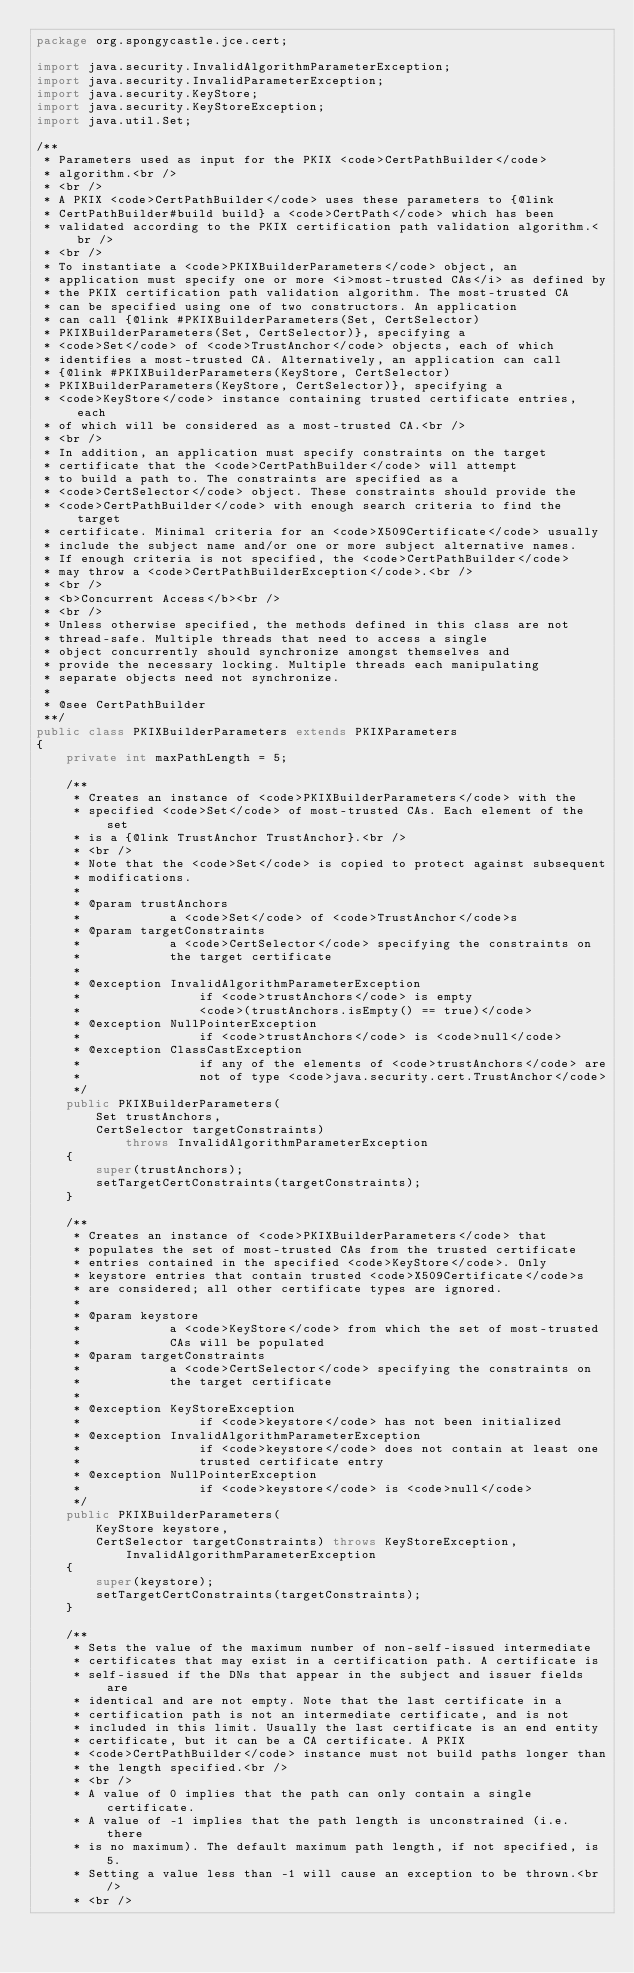Convert code to text. <code><loc_0><loc_0><loc_500><loc_500><_Java_>package org.spongycastle.jce.cert;

import java.security.InvalidAlgorithmParameterException;
import java.security.InvalidParameterException;
import java.security.KeyStore;
import java.security.KeyStoreException;
import java.util.Set;

/**
 * Parameters used as input for the PKIX <code>CertPathBuilder</code> 
 * algorithm.<br />
 * <br />
 * A PKIX <code>CertPathBuilder</code> uses these parameters to {@link 
 * CertPathBuilder#build build} a <code>CertPath</code> which has been 
 * validated according to the PKIX certification path validation algorithm.<br />
 * <br />
 * To instantiate a <code>PKIXBuilderParameters</code> object, an
 * application must specify one or more <i>most-trusted CAs</i> as defined by
 * the PKIX certification path validation algorithm. The most-trusted CA 
 * can be specified using one of two constructors. An application 
 * can call {@link #PKIXBuilderParameters(Set, CertSelector) 
 * PKIXBuilderParameters(Set, CertSelector)}, specifying a 
 * <code>Set</code> of <code>TrustAnchor</code> objects, each of which 
 * identifies a most-trusted CA. Alternatively, an application can call 
 * {@link #PKIXBuilderParameters(KeyStore, CertSelector)
 * PKIXBuilderParameters(KeyStore, CertSelector)}, specifying a 
 * <code>KeyStore</code> instance containing trusted certificate entries, each 
 * of which will be considered as a most-trusted CA.<br />
 * <br />
 * In addition, an application must specify constraints on the target 
 * certificate that the <code>CertPathBuilder</code> will attempt 
 * to build a path to. The constraints are specified as a 
 * <code>CertSelector</code> object. These constraints should provide the 
 * <code>CertPathBuilder</code> with enough search criteria to find the target 
 * certificate. Minimal criteria for an <code>X509Certificate</code> usually 
 * include the subject name and/or one or more subject alternative names.
 * If enough criteria is not specified, the <code>CertPathBuilder</code> 
 * may throw a <code>CertPathBuilderException</code>.<br />
 * <br />
 * <b>Concurrent Access</b><br />
 * <br />
 * Unless otherwise specified, the methods defined in this class are not
 * thread-safe. Multiple threads that need to access a single
 * object concurrently should synchronize amongst themselves and
 * provide the necessary locking. Multiple threads each manipulating
 * separate objects need not synchronize.
 *
 * @see CertPathBuilder
 **/
public class PKIXBuilderParameters extends PKIXParameters
{
    private int maxPathLength = 5;

    /**
     * Creates an instance of <code>PKIXBuilderParameters</code> with the
     * specified <code>Set</code> of most-trusted CAs. Each element of the set
     * is a {@link TrustAnchor TrustAnchor}.<br />
     * <br />
     * Note that the <code>Set</code> is copied to protect against subsequent
     * modifications.
     * 
     * @param trustAnchors
     *            a <code>Set</code> of <code>TrustAnchor</code>s
     * @param targetConstraints
     *            a <code>CertSelector</code> specifying the constraints on
     *            the target certificate
     * 
     * @exception InvalidAlgorithmParameterException
     *                if <code>trustAnchors</code> is empty
     *                <code>(trustAnchors.isEmpty() == true)</code>
     * @exception NullPointerException
     *                if <code>trustAnchors</code> is <code>null</code>
     * @exception ClassCastException
     *                if any of the elements of <code>trustAnchors</code> are
     *                not of type <code>java.security.cert.TrustAnchor</code>
     */
    public PKIXBuilderParameters(
        Set trustAnchors,
        CertSelector targetConstraints)
            throws InvalidAlgorithmParameterException
    {
        super(trustAnchors);
        setTargetCertConstraints(targetConstraints);
    }

    /**
     * Creates an instance of <code>PKIXBuilderParameters</code> that
     * populates the set of most-trusted CAs from the trusted certificate
     * entries contained in the specified <code>KeyStore</code>. Only
     * keystore entries that contain trusted <code>X509Certificate</code>s
     * are considered; all other certificate types are ignored.
     * 
     * @param keystore
     *            a <code>KeyStore</code> from which the set of most-trusted
     *            CAs will be populated
     * @param targetConstraints
     *            a <code>CertSelector</code> specifying the constraints on
     *            the target certificate
     * 
     * @exception KeyStoreException
     *                if <code>keystore</code> has not been initialized
     * @exception InvalidAlgorithmParameterException
     *                if <code>keystore</code> does not contain at least one
     *                trusted certificate entry
     * @exception NullPointerException
     *                if <code>keystore</code> is <code>null</code>
     */
    public PKIXBuilderParameters(
        KeyStore keystore,
        CertSelector targetConstraints) throws KeyStoreException,
            InvalidAlgorithmParameterException
    {
        super(keystore);
        setTargetCertConstraints(targetConstraints);
    }

    /**
     * Sets the value of the maximum number of non-self-issued intermediate
     * certificates that may exist in a certification path. A certificate is
     * self-issued if the DNs that appear in the subject and issuer fields are
     * identical and are not empty. Note that the last certificate in a
     * certification path is not an intermediate certificate, and is not
     * included in this limit. Usually the last certificate is an end entity
     * certificate, but it can be a CA certificate. A PKIX
     * <code>CertPathBuilder</code> instance must not build paths longer than
     * the length specified.<br />
     * <br />
     * A value of 0 implies that the path can only contain a single certificate.
     * A value of -1 implies that the path length is unconstrained (i.e. there
     * is no maximum). The default maximum path length, if not specified, is 5.
     * Setting a value less than -1 will cause an exception to be thrown.<br />
     * <br /></code> 